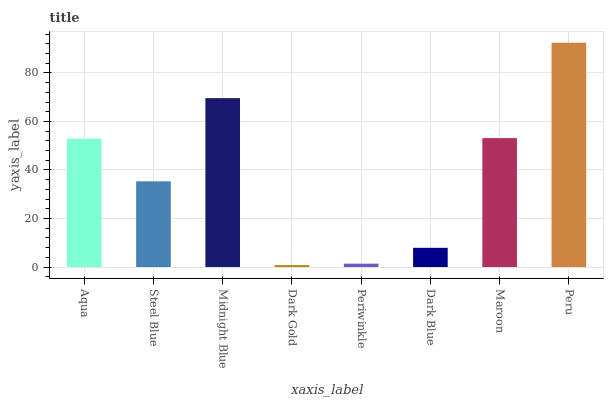Is Dark Gold the minimum?
Answer yes or no. Yes. Is Peru the maximum?
Answer yes or no. Yes. Is Steel Blue the minimum?
Answer yes or no. No. Is Steel Blue the maximum?
Answer yes or no. No. Is Aqua greater than Steel Blue?
Answer yes or no. Yes. Is Steel Blue less than Aqua?
Answer yes or no. Yes. Is Steel Blue greater than Aqua?
Answer yes or no. No. Is Aqua less than Steel Blue?
Answer yes or no. No. Is Aqua the high median?
Answer yes or no. Yes. Is Steel Blue the low median?
Answer yes or no. Yes. Is Dark Gold the high median?
Answer yes or no. No. Is Dark Blue the low median?
Answer yes or no. No. 